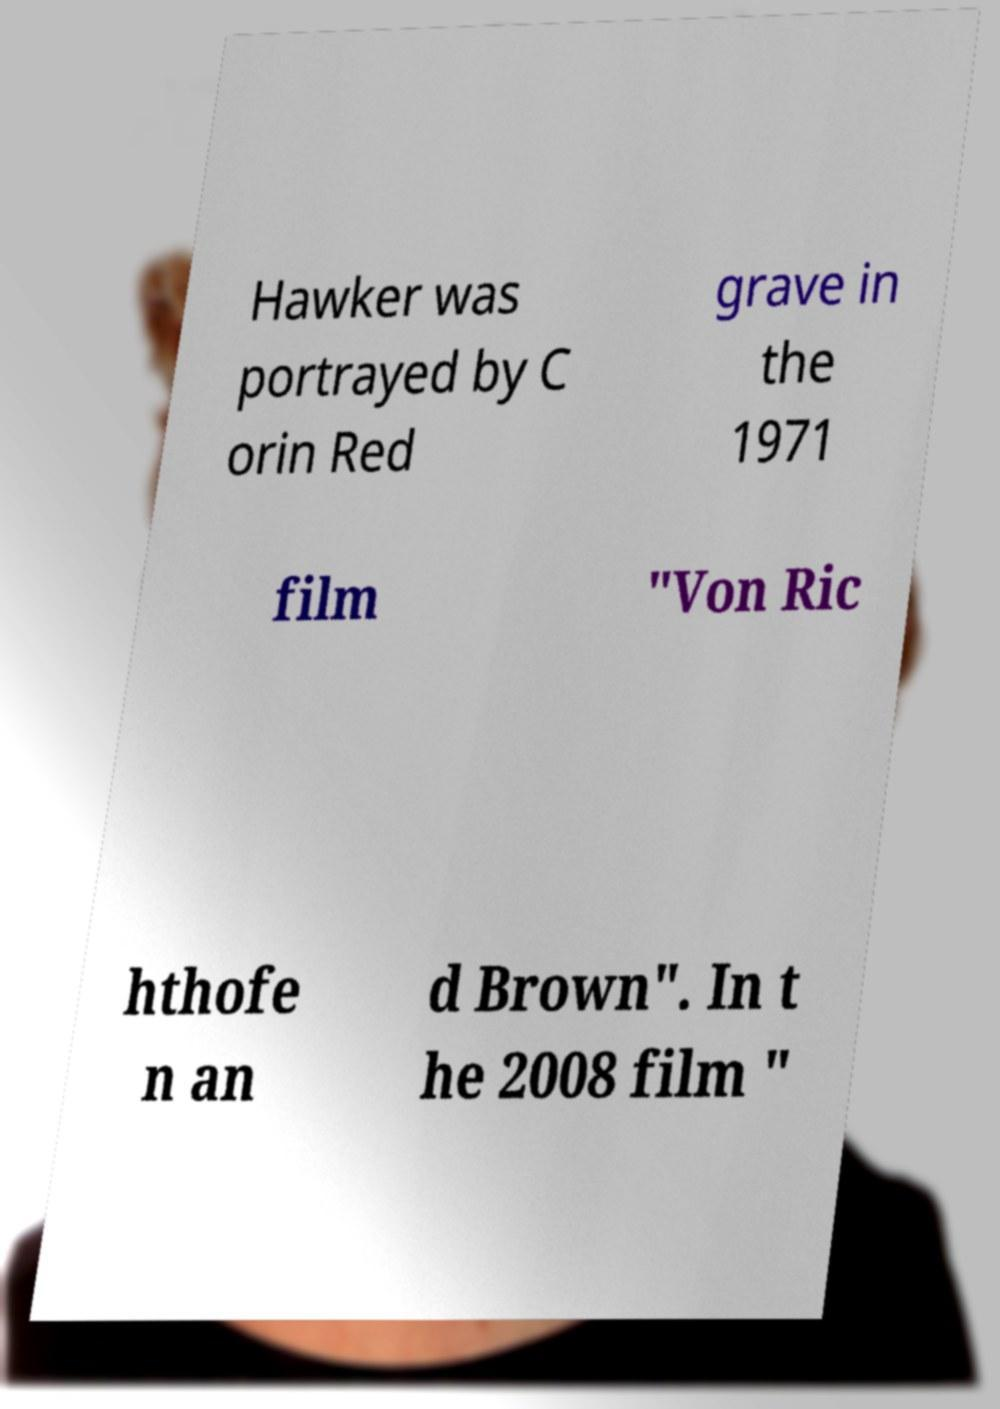Could you assist in decoding the text presented in this image and type it out clearly? Hawker was portrayed by C orin Red grave in the 1971 film "Von Ric hthofe n an d Brown". In t he 2008 film " 